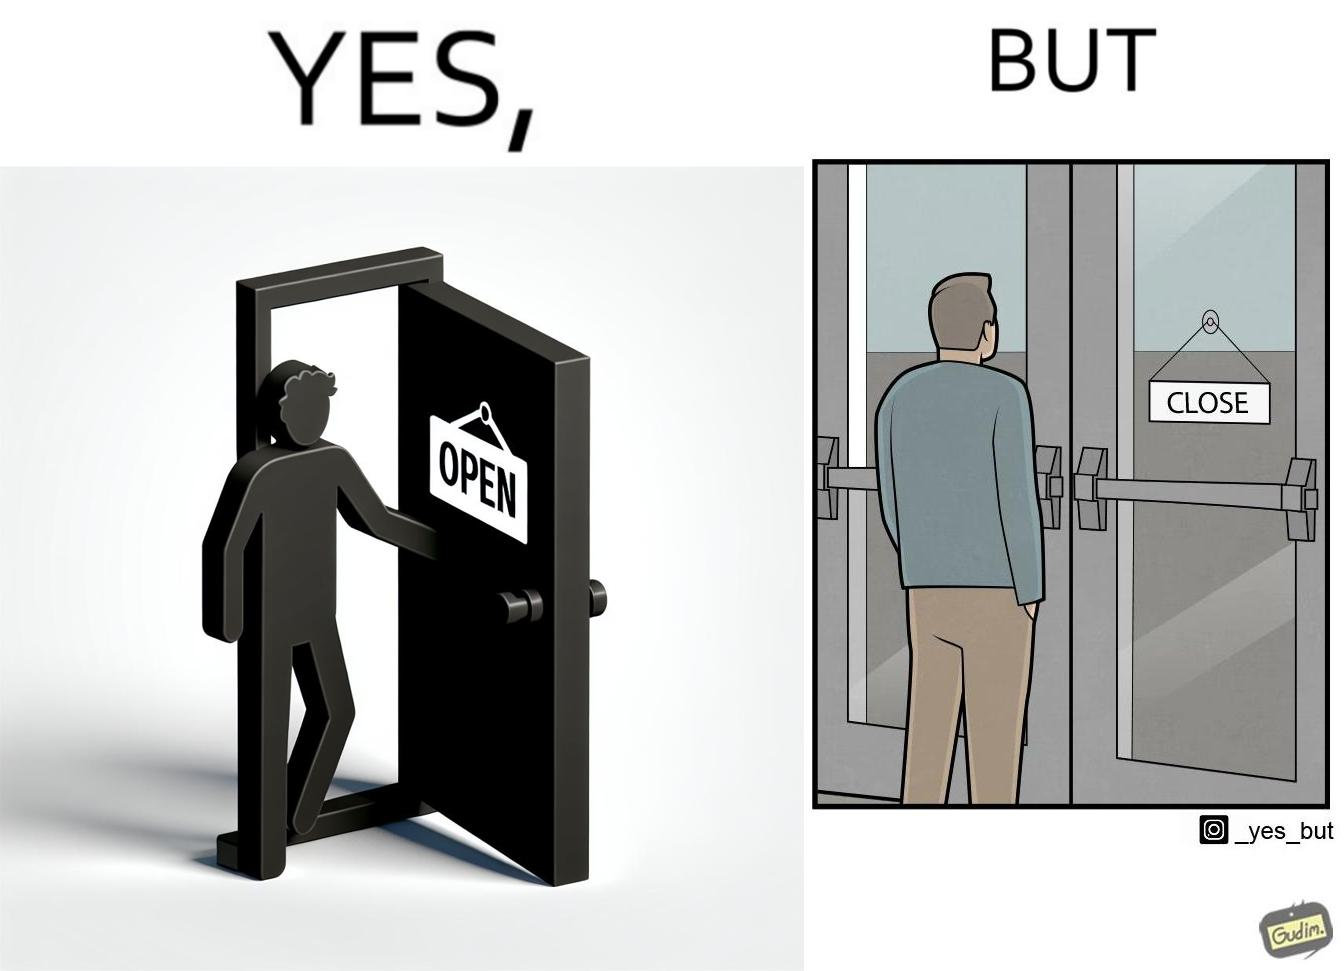Explain the humor or irony in this image. The image is funny because a person opens a door with the sign 'OPEN', meaning the place is open. However, once the person enters the building and looks back, the other side of the sign reads 'CLOSE', which ideally should not be the case, as the place is actually open. 